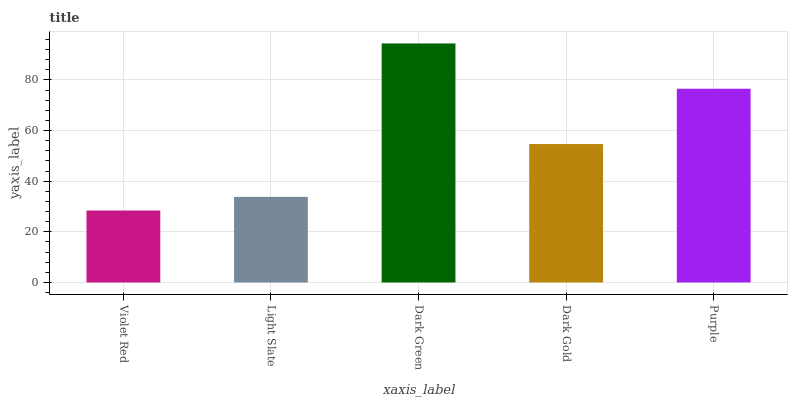Is Light Slate the minimum?
Answer yes or no. No. Is Light Slate the maximum?
Answer yes or no. No. Is Light Slate greater than Violet Red?
Answer yes or no. Yes. Is Violet Red less than Light Slate?
Answer yes or no. Yes. Is Violet Red greater than Light Slate?
Answer yes or no. No. Is Light Slate less than Violet Red?
Answer yes or no. No. Is Dark Gold the high median?
Answer yes or no. Yes. Is Dark Gold the low median?
Answer yes or no. Yes. Is Dark Green the high median?
Answer yes or no. No. Is Violet Red the low median?
Answer yes or no. No. 